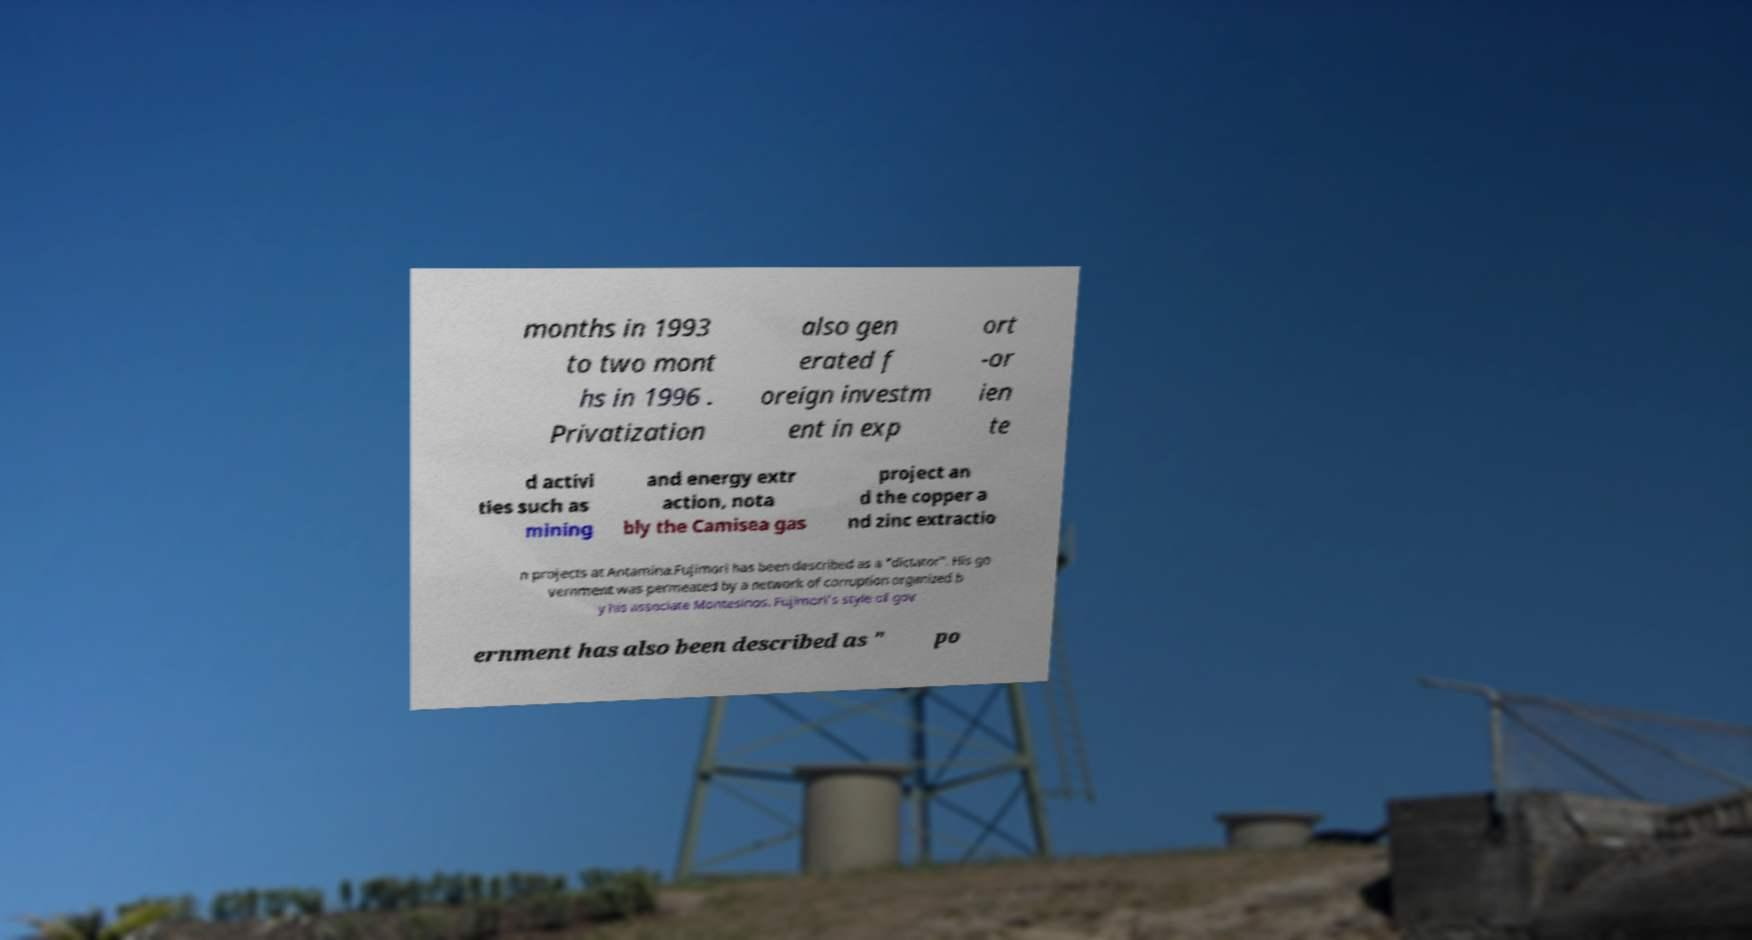There's text embedded in this image that I need extracted. Can you transcribe it verbatim? months in 1993 to two mont hs in 1996 . Privatization also gen erated f oreign investm ent in exp ort -or ien te d activi ties such as mining and energy extr action, nota bly the Camisea gas project an d the copper a nd zinc extractio n projects at Antamina.Fujimori has been described as a "dictator". His go vernment was permeated by a network of corruption organized b y his associate Montesinos. Fujimori's style of gov ernment has also been described as " po 